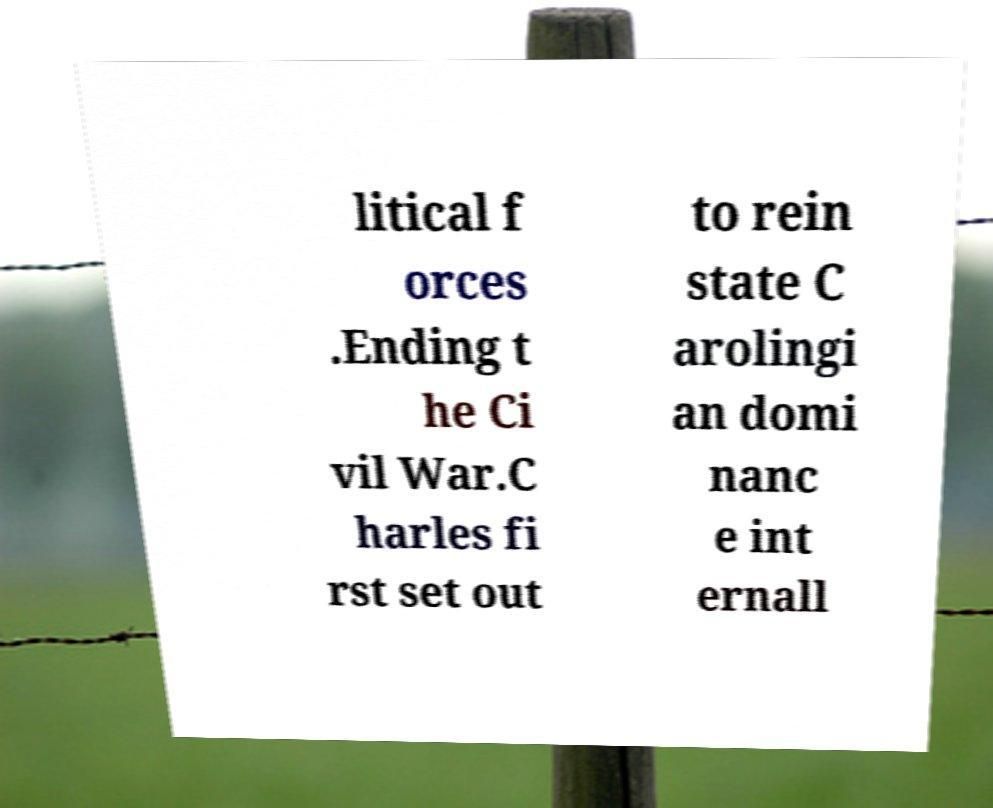Could you assist in decoding the text presented in this image and type it out clearly? litical f orces .Ending t he Ci vil War.C harles fi rst set out to rein state C arolingi an domi nanc e int ernall 